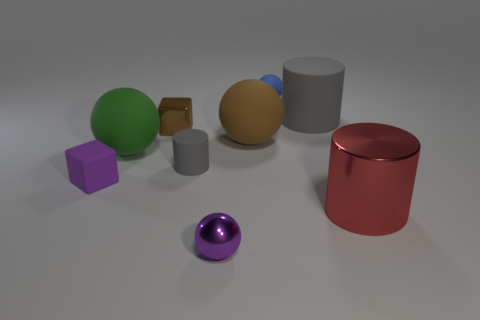Subtract 1 cylinders. How many cylinders are left? 2 Subtract all green balls. How many balls are left? 3 Subtract all big green spheres. How many spheres are left? 3 Subtract all yellow balls. Subtract all green cylinders. How many balls are left? 4 Add 1 small yellow balls. How many objects exist? 10 Subtract 1 green spheres. How many objects are left? 8 Subtract all blocks. How many objects are left? 7 Subtract all small matte balls. Subtract all tiny brown metallic cubes. How many objects are left? 7 Add 2 tiny blue things. How many tiny blue things are left? 3 Add 2 big red metallic objects. How many big red metallic objects exist? 3 